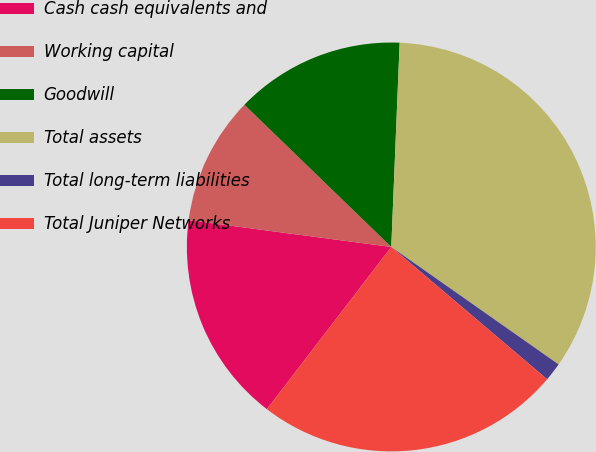Convert chart. <chart><loc_0><loc_0><loc_500><loc_500><pie_chart><fcel>Cash cash equivalents and<fcel>Working capital<fcel>Goodwill<fcel>Total assets<fcel>Total long-term liabilities<fcel>Total Juniper Networks<nl><fcel>16.68%<fcel>10.15%<fcel>13.41%<fcel>34.09%<fcel>1.46%<fcel>24.21%<nl></chart> 